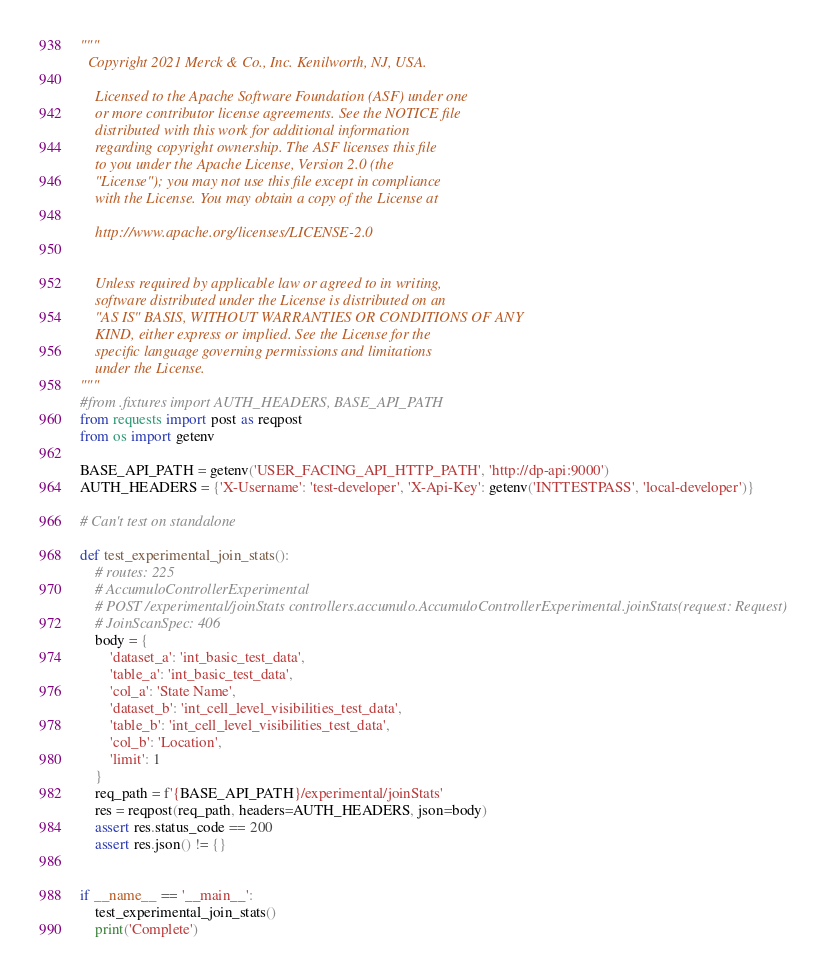Convert code to text. <code><loc_0><loc_0><loc_500><loc_500><_Python_>"""
  Copyright 2021 Merck & Co., Inc. Kenilworth, NJ, USA.
 
 	Licensed to the Apache Software Foundation (ASF) under one
 	or more contributor license agreements. See the NOTICE file
 	distributed with this work for additional information
 	regarding copyright ownership. The ASF licenses this file
 	to you under the Apache License, Version 2.0 (the
 	"License"); you may not use this file except in compliance
 	with the License. You may obtain a copy of the License at
 
 	http://www.apache.org/licenses/LICENSE-2.0
 
 
 	Unless required by applicable law or agreed to in writing,
 	software distributed under the License is distributed on an
 	"AS IS" BASIS, WITHOUT WARRANTIES OR CONDITIONS OF ANY
 	KIND, either express or implied. See the License for the
 	specific language governing permissions and limitations
 	under the License.
"""
#from .fixtures import AUTH_HEADERS, BASE_API_PATH
from requests import post as reqpost
from os import getenv

BASE_API_PATH = getenv('USER_FACING_API_HTTP_PATH', 'http://dp-api:9000')
AUTH_HEADERS = {'X-Username': 'test-developer', 'X-Api-Key': getenv('INTTESTPASS', 'local-developer')}

# Can't test on standalone

def test_experimental_join_stats():
    # routes: 225
    # AccumuloControllerExperimental
    # POST /experimental/joinStats controllers.accumulo.AccumuloControllerExperimental.joinStats(request: Request)
    # JoinScanSpec: 406
    body = {
        'dataset_a': 'int_basic_test_data',
        'table_a': 'int_basic_test_data',
        'col_a': 'State Name',
        'dataset_b': 'int_cell_level_visibilities_test_data',
        'table_b': 'int_cell_level_visibilities_test_data',
        'col_b': 'Location',
        'limit': 1
    }
    req_path = f'{BASE_API_PATH}/experimental/joinStats'
    res = reqpost(req_path, headers=AUTH_HEADERS, json=body)
    assert res.status_code == 200
    assert res.json() != {}


if __name__ == '__main__':
    test_experimental_join_stats()
    print('Complete')
</code> 